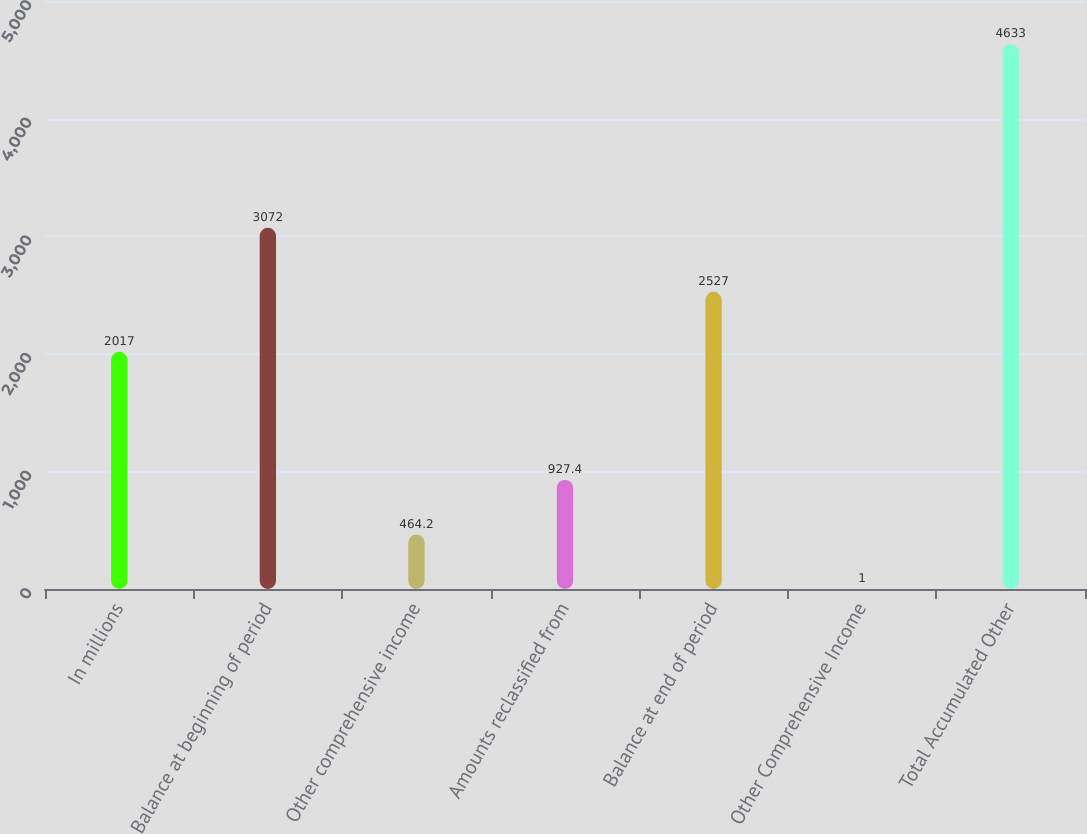Convert chart to OTSL. <chart><loc_0><loc_0><loc_500><loc_500><bar_chart><fcel>In millions<fcel>Balance at beginning of period<fcel>Other comprehensive income<fcel>Amounts reclassified from<fcel>Balance at end of period<fcel>Other Comprehensive Income<fcel>Total Accumulated Other<nl><fcel>2017<fcel>3072<fcel>464.2<fcel>927.4<fcel>2527<fcel>1<fcel>4633<nl></chart> 